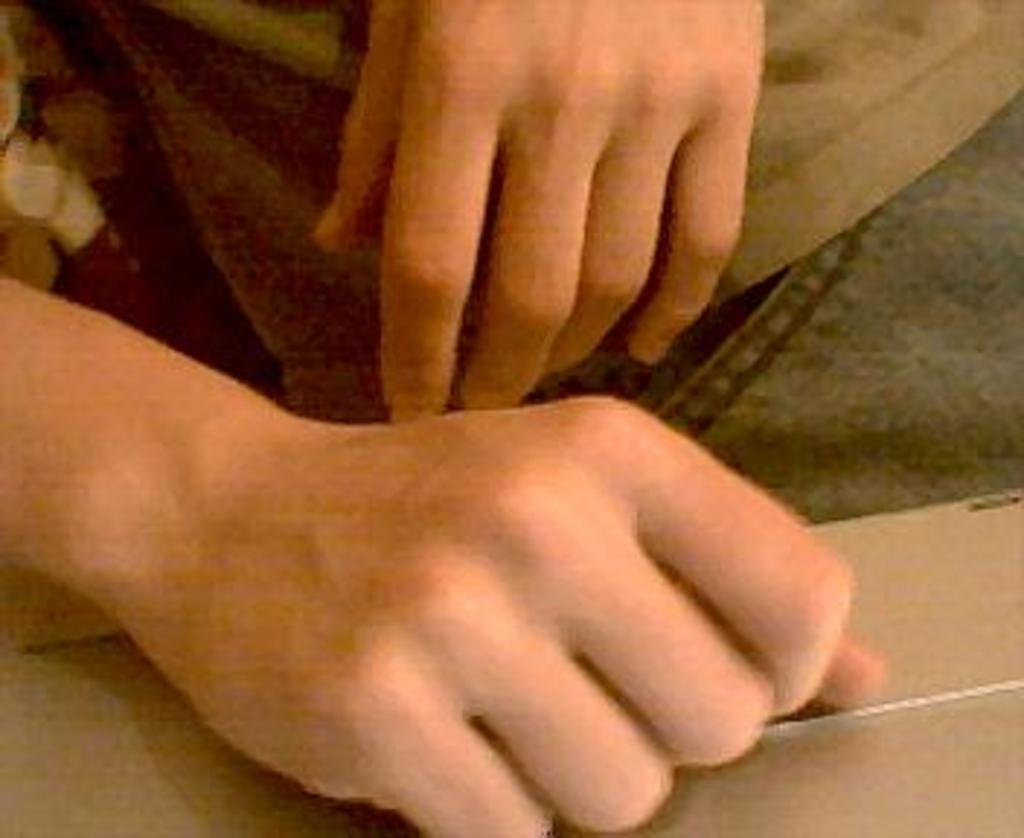What can be seen in the image? There are two hands in the image. What title is associated with the gun in the image? There is no gun present in the image, so there is no title associated with it. 